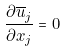Convert formula to latex. <formula><loc_0><loc_0><loc_500><loc_500>\frac { \partial \overline { u } _ { j } } { \partial x _ { j } } = 0</formula> 